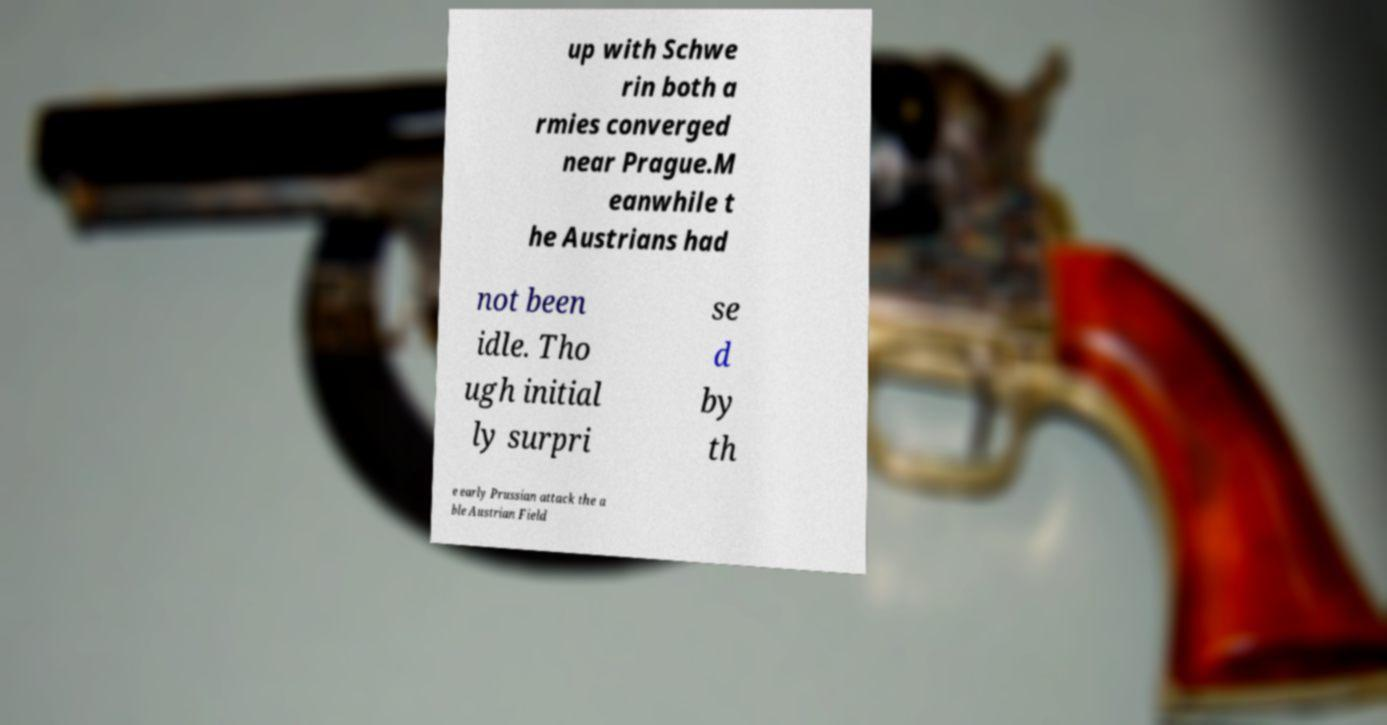Can you read and provide the text displayed in the image?This photo seems to have some interesting text. Can you extract and type it out for me? up with Schwe rin both a rmies converged near Prague.M eanwhile t he Austrians had not been idle. Tho ugh initial ly surpri se d by th e early Prussian attack the a ble Austrian Field 